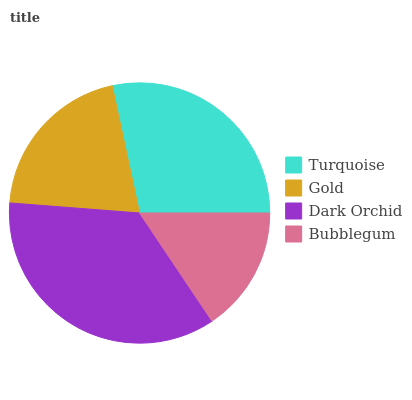Is Bubblegum the minimum?
Answer yes or no. Yes. Is Dark Orchid the maximum?
Answer yes or no. Yes. Is Gold the minimum?
Answer yes or no. No. Is Gold the maximum?
Answer yes or no. No. Is Turquoise greater than Gold?
Answer yes or no. Yes. Is Gold less than Turquoise?
Answer yes or no. Yes. Is Gold greater than Turquoise?
Answer yes or no. No. Is Turquoise less than Gold?
Answer yes or no. No. Is Turquoise the high median?
Answer yes or no. Yes. Is Gold the low median?
Answer yes or no. Yes. Is Dark Orchid the high median?
Answer yes or no. No. Is Turquoise the low median?
Answer yes or no. No. 